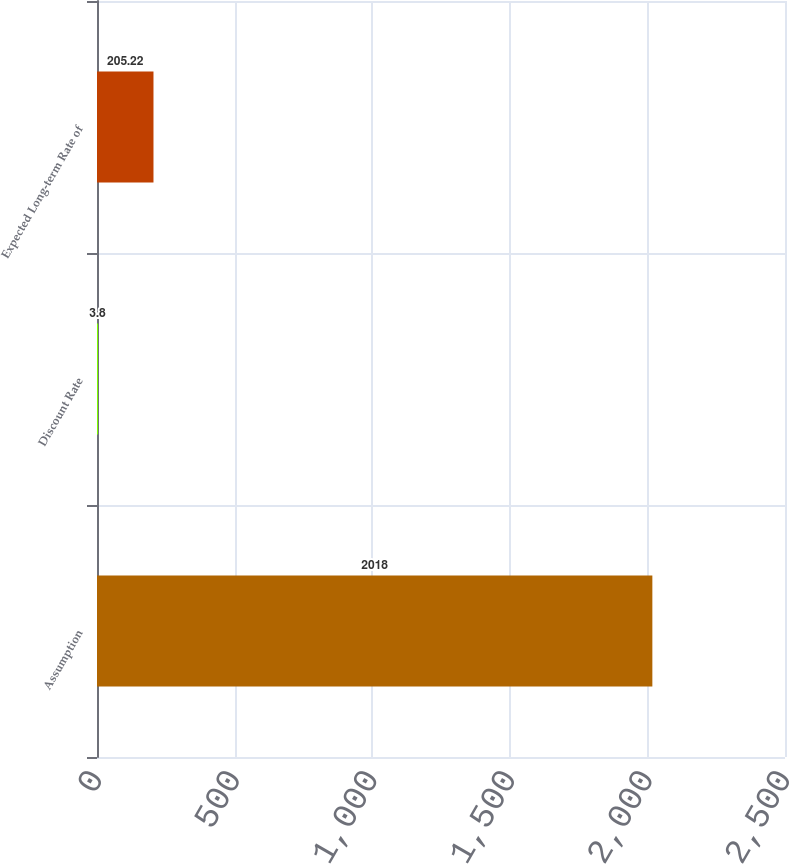<chart> <loc_0><loc_0><loc_500><loc_500><bar_chart><fcel>Assumption<fcel>Discount Rate<fcel>Expected Long-term Rate of<nl><fcel>2018<fcel>3.8<fcel>205.22<nl></chart> 